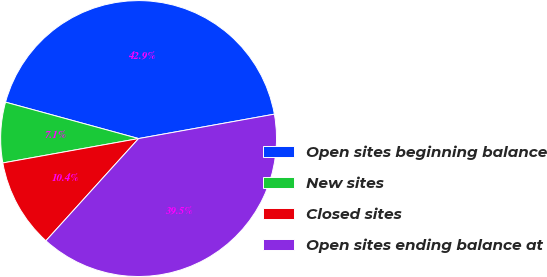Convert chart to OTSL. <chart><loc_0><loc_0><loc_500><loc_500><pie_chart><fcel>Open sites beginning balance<fcel>New sites<fcel>Closed sites<fcel>Open sites ending balance at<nl><fcel>42.92%<fcel>7.08%<fcel>10.45%<fcel>39.55%<nl></chart> 